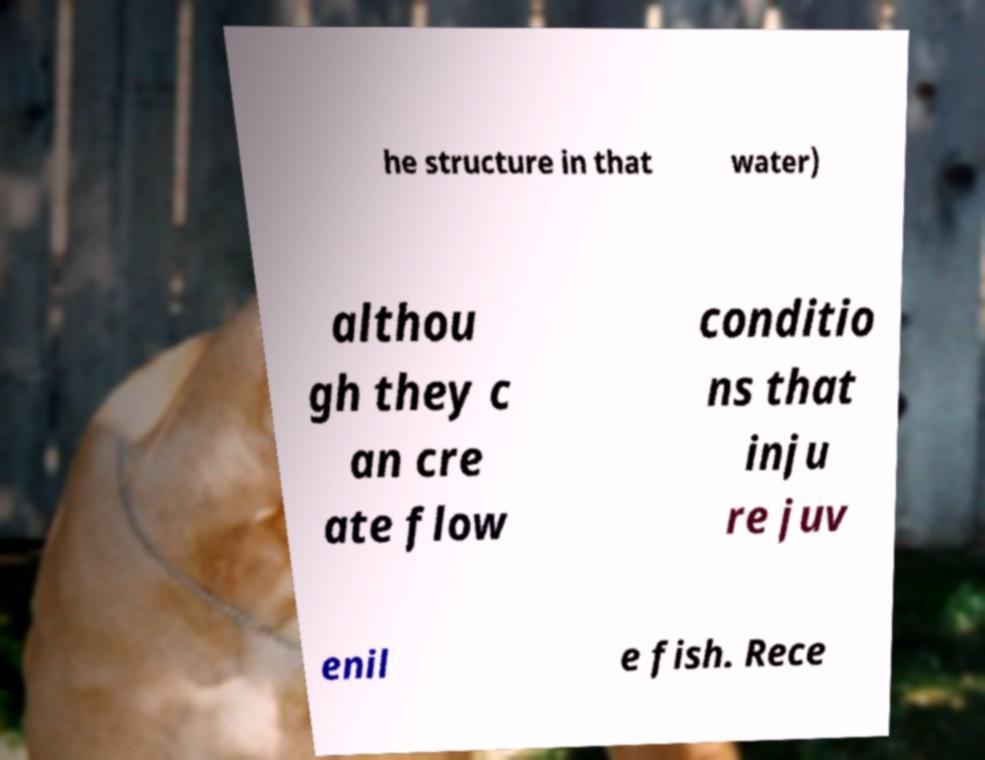Could you extract and type out the text from this image? he structure in that water) althou gh they c an cre ate flow conditio ns that inju re juv enil e fish. Rece 